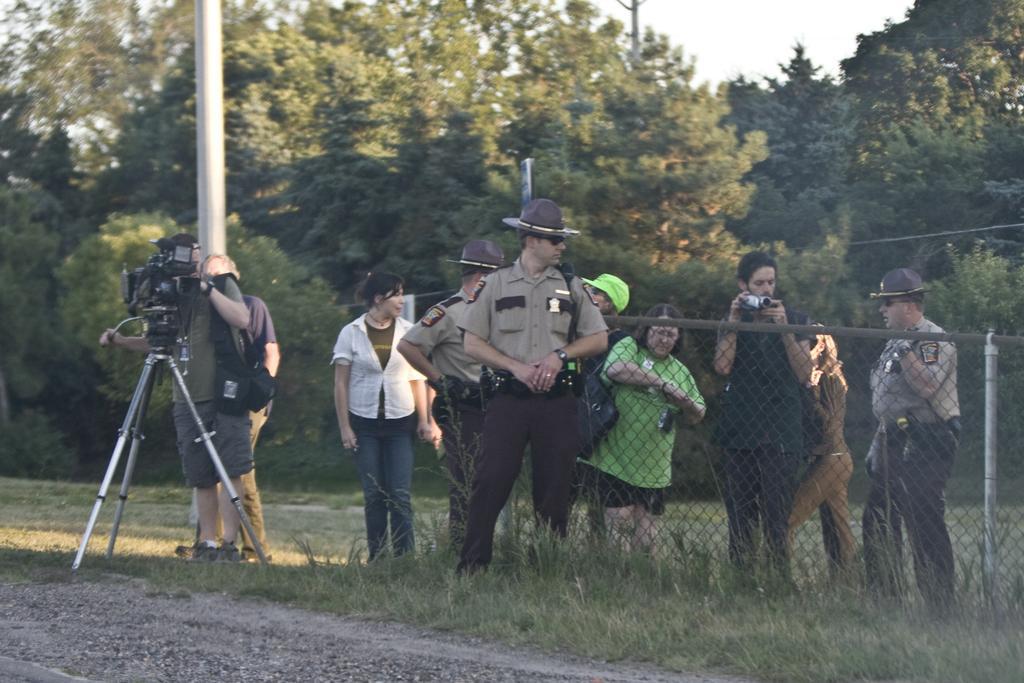Could you give a brief overview of what you see in this image? In this image we can see there are a few people standing on the surface of the grass, one of them is holding a camera. In the background there are trees and sky. 